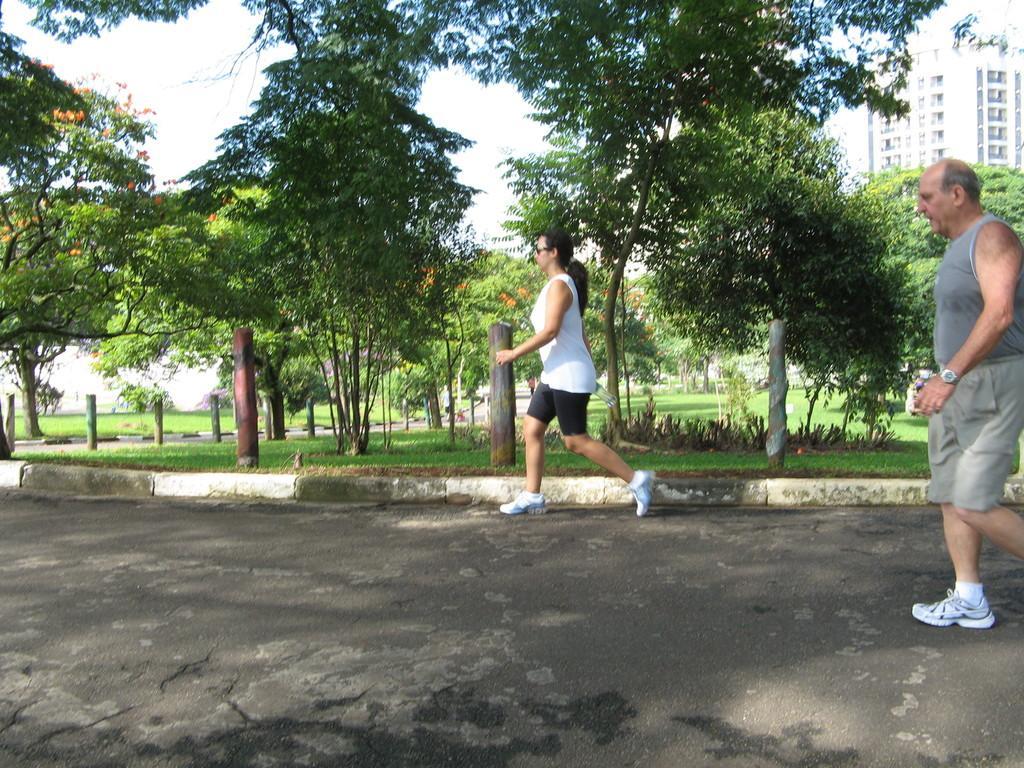Could you give a brief overview of what you see in this image? In this picture, we see the man and the women are running on the road. Beside them, we see the poles and the grass. There are trees and buildings in the background. At the bottom, we see the sky. This picture might be clicked in the park. 